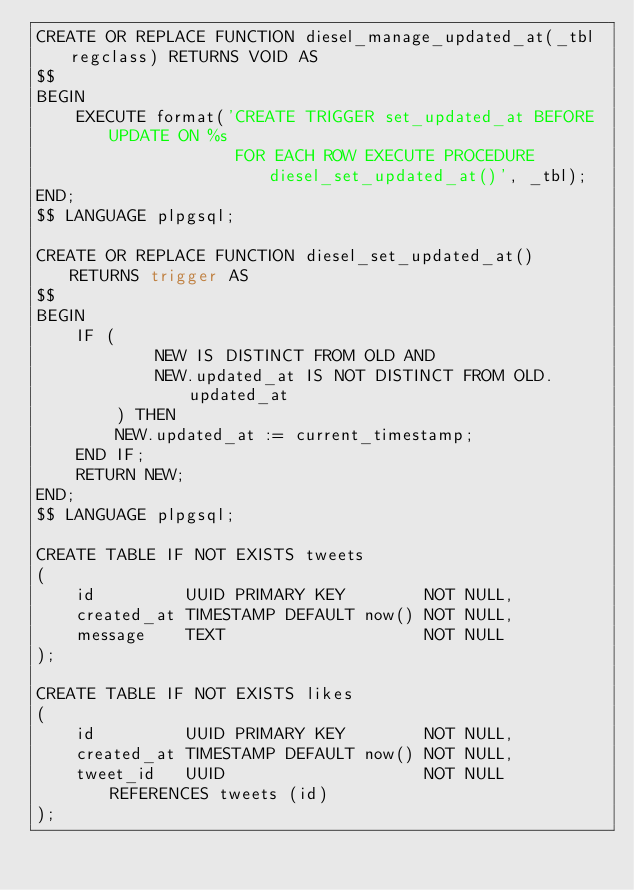Convert code to text. <code><loc_0><loc_0><loc_500><loc_500><_SQL_>CREATE OR REPLACE FUNCTION diesel_manage_updated_at(_tbl regclass) RETURNS VOID AS
$$
BEGIN
    EXECUTE format('CREATE TRIGGER set_updated_at BEFORE UPDATE ON %s
                    FOR EACH ROW EXECUTE PROCEDURE diesel_set_updated_at()', _tbl);
END;
$$ LANGUAGE plpgsql;

CREATE OR REPLACE FUNCTION diesel_set_updated_at() RETURNS trigger AS
$$
BEGIN
    IF (
            NEW IS DISTINCT FROM OLD AND
            NEW.updated_at IS NOT DISTINCT FROM OLD.updated_at
        ) THEN
        NEW.updated_at := current_timestamp;
    END IF;
    RETURN NEW;
END;
$$ LANGUAGE plpgsql;

CREATE TABLE IF NOT EXISTS tweets
(
    id         UUID PRIMARY KEY        NOT NULL,
    created_at TIMESTAMP DEFAULT now() NOT NULL,
    message    TEXT                    NOT NULL
);

CREATE TABLE IF NOT EXISTS likes
(
    id         UUID PRIMARY KEY        NOT NULL,
    created_at TIMESTAMP DEFAULT now() NOT NULL,
    tweet_id   UUID                    NOT NULL REFERENCES tweets (id)
);
</code> 